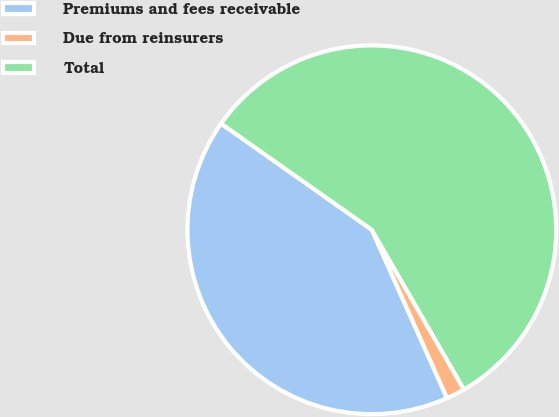<chart> <loc_0><loc_0><loc_500><loc_500><pie_chart><fcel>Premiums and fees receivable<fcel>Due from reinsurers<fcel>Total<nl><fcel>41.46%<fcel>1.64%<fcel>56.91%<nl></chart> 